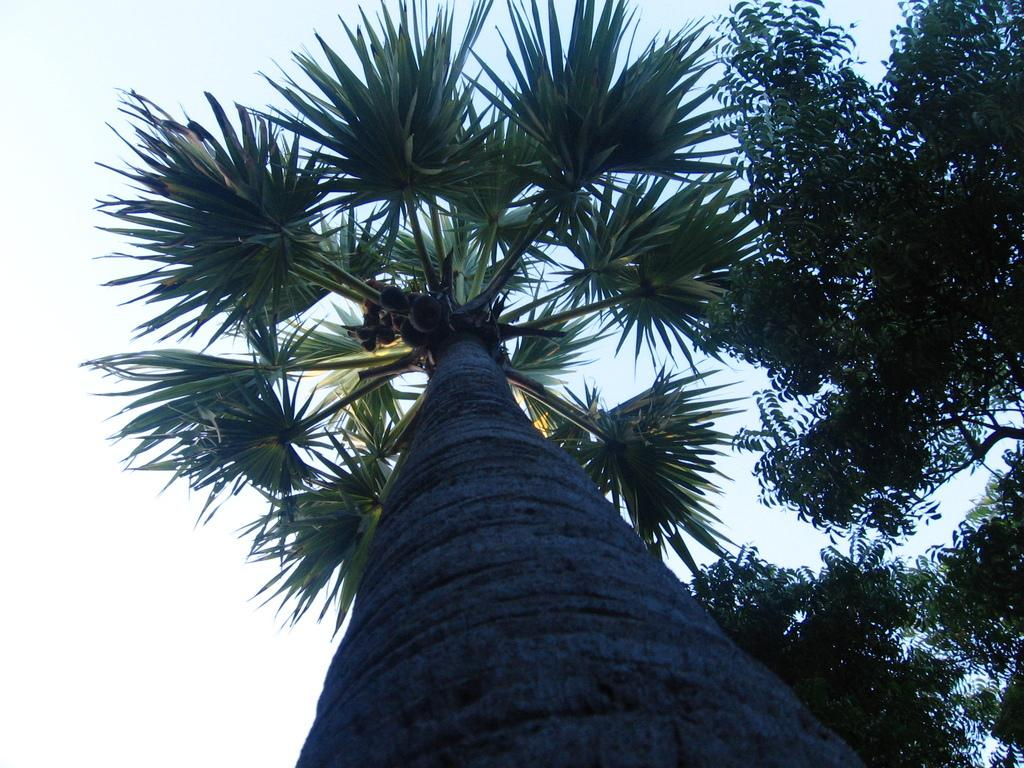What type of tree is located in the middle of the image? There is a palm tree in the middle of the image. What other tree can be seen beside the palm tree? There is a neem tree beside the palm tree. What is visible above the trees in the image? The sky is visible above the trees in the image. Can you tell me how many birds are sitting on the vase in the image? There is no vase present in the image, and therefore no birds can be seen sitting on it. 